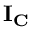Convert formula to latex. <formula><loc_0><loc_0><loc_500><loc_500>I _ { C }</formula> 